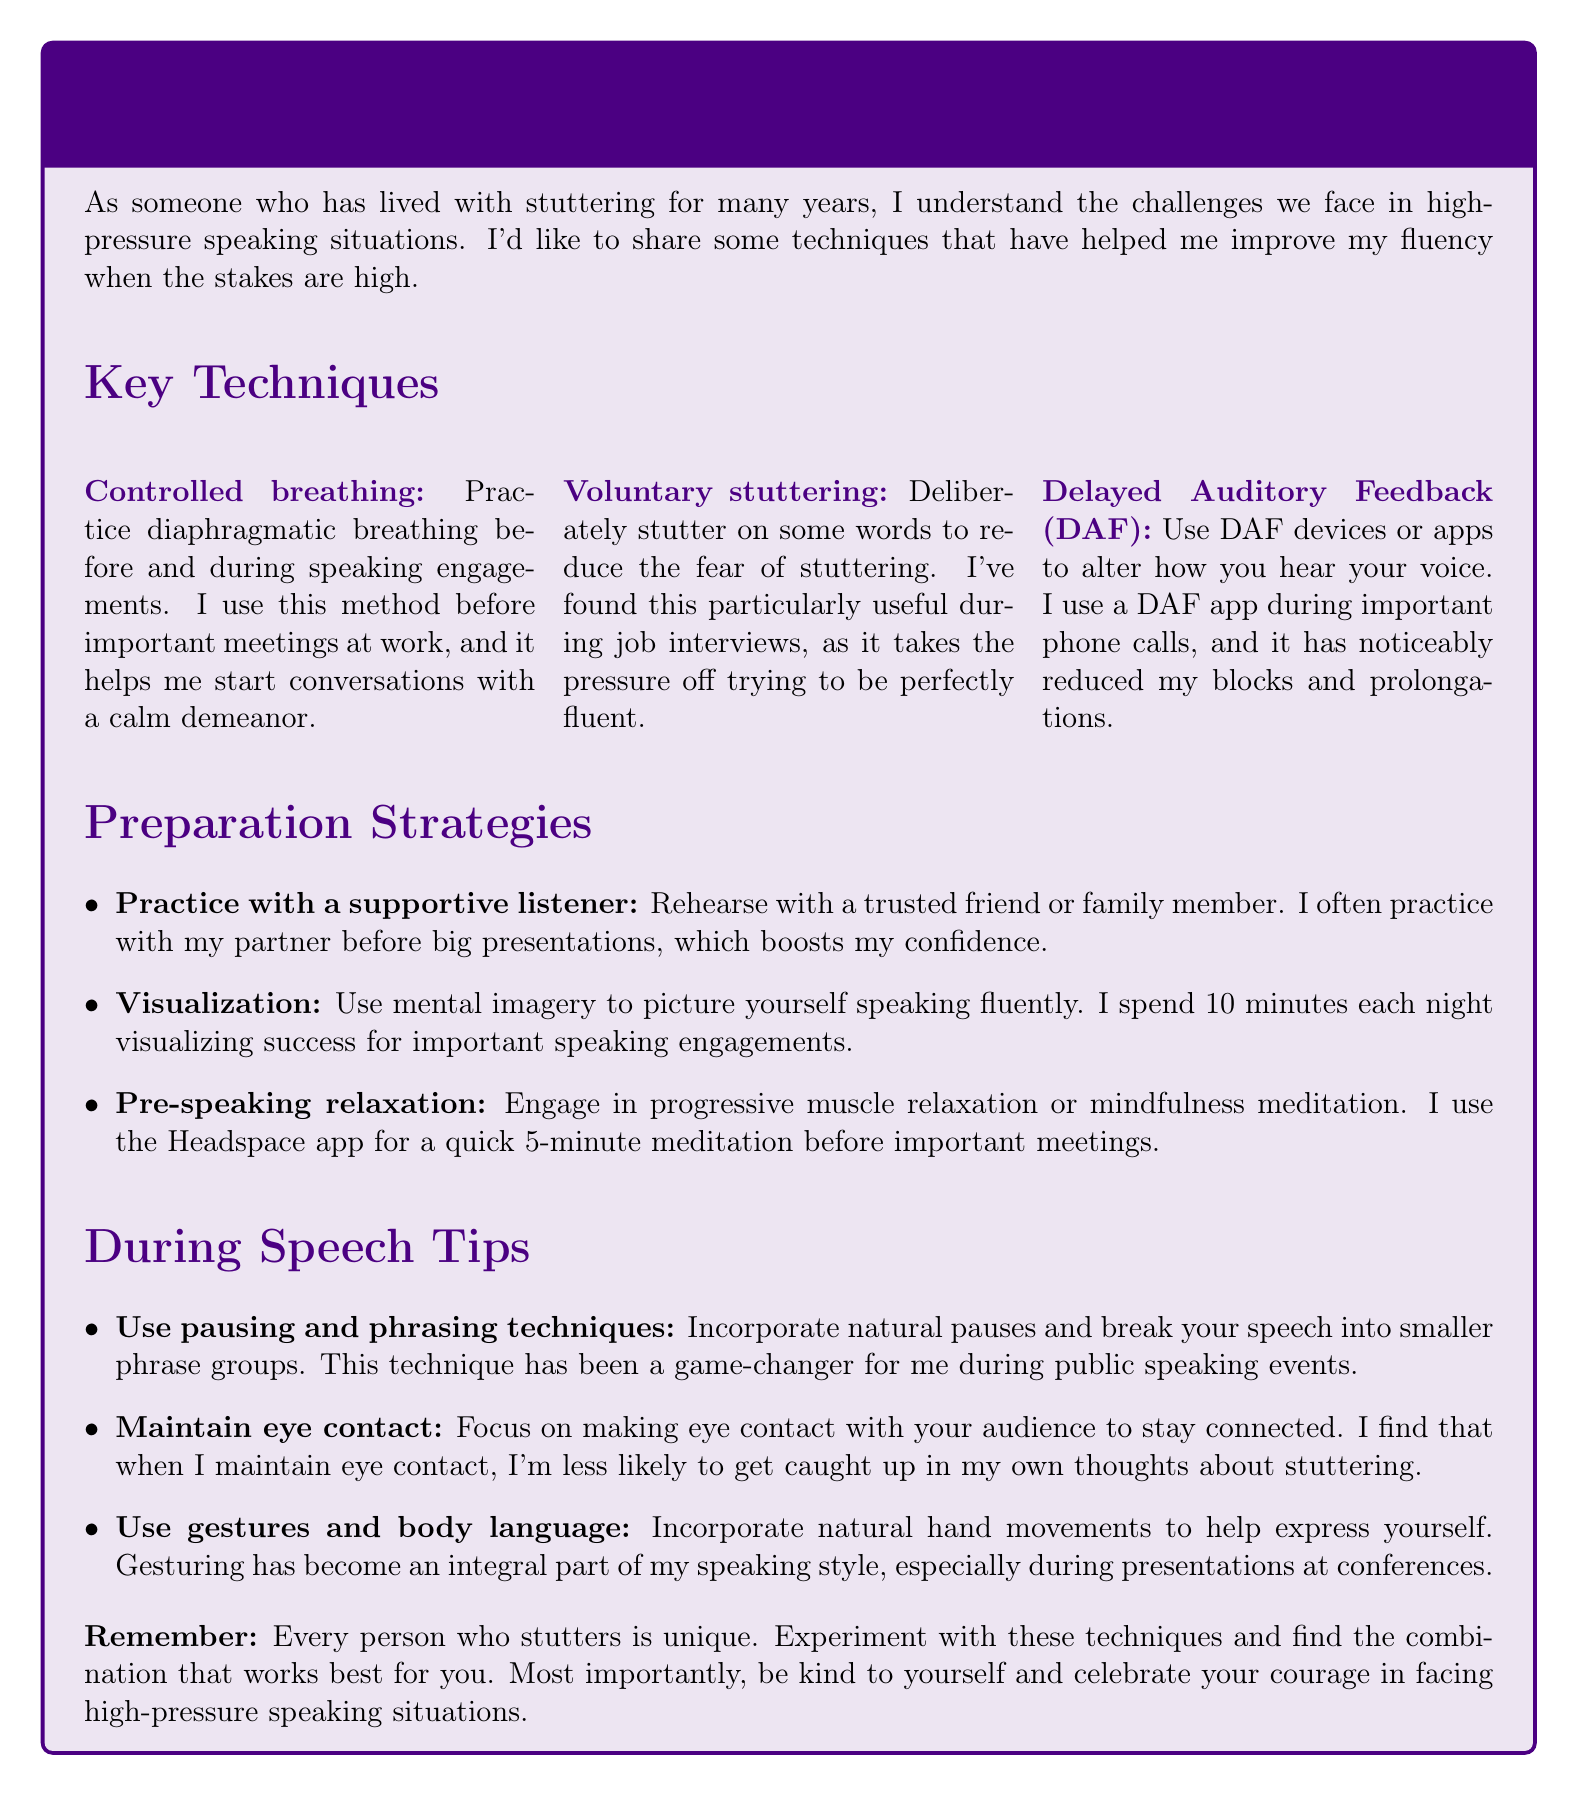What is the title of the memo? The title of the memo is presented at the beginning of the document.
Answer: Managing Stuttering in High-Pressure Speaking Situations: Tips from a Fellow Stutterer How many key techniques are listed in the memo? The number of techniques is counted in the section provided.
Answer: 3 What breathing technique is recommended? The memo describes various techniques, including one focused on breathing.
Answer: Controlled breathing Who popularized the voluntary stuttering technique? The memo mentions a specific individual associated with the technique.
Answer: Dr. Joseph Sheehan What app is suggested for relaxation before speaking? The memo provides a specific app for relaxation exercises.
Answer: Headspace Which technique is described as a game-changer during public speaking? This refers to a technique discussed in the 'During Speech Tips' section.
Answer: Use pausing and phrasing techniques What personal experience is shared regarding the DAF app? The memo includes a personal experience related to the use of the DAF app.
Answer: It has noticeably reduced my blocks and prolongations 